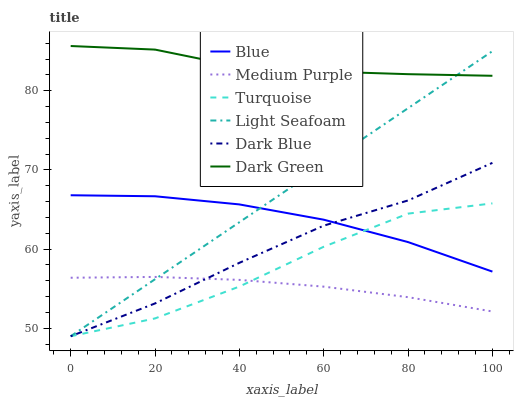Does Medium Purple have the minimum area under the curve?
Answer yes or no. Yes. Does Dark Green have the maximum area under the curve?
Answer yes or no. Yes. Does Turquoise have the minimum area under the curve?
Answer yes or no. No. Does Turquoise have the maximum area under the curve?
Answer yes or no. No. Is Light Seafoam the smoothest?
Answer yes or no. Yes. Is Turquoise the roughest?
Answer yes or no. Yes. Is Medium Purple the smoothest?
Answer yes or no. No. Is Medium Purple the roughest?
Answer yes or no. No. Does Turquoise have the lowest value?
Answer yes or no. Yes. Does Medium Purple have the lowest value?
Answer yes or no. No. Does Dark Green have the highest value?
Answer yes or no. Yes. Does Turquoise have the highest value?
Answer yes or no. No. Is Dark Blue less than Dark Green?
Answer yes or no. Yes. Is Dark Green greater than Turquoise?
Answer yes or no. Yes. Does Light Seafoam intersect Turquoise?
Answer yes or no. Yes. Is Light Seafoam less than Turquoise?
Answer yes or no. No. Is Light Seafoam greater than Turquoise?
Answer yes or no. No. Does Dark Blue intersect Dark Green?
Answer yes or no. No. 